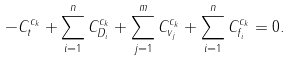Convert formula to latex. <formula><loc_0><loc_0><loc_500><loc_500>- C ^ { c _ { k } } _ { t } + \sum _ { i = 1 } ^ { n } C _ { D _ { i } } ^ { c _ { k } } + \sum _ { j = 1 } ^ { m } C _ { v _ { j } } ^ { c _ { k } } + \sum _ { i = 1 } ^ { n } C _ { f _ { i } } ^ { c _ { k } } = 0 .</formula> 